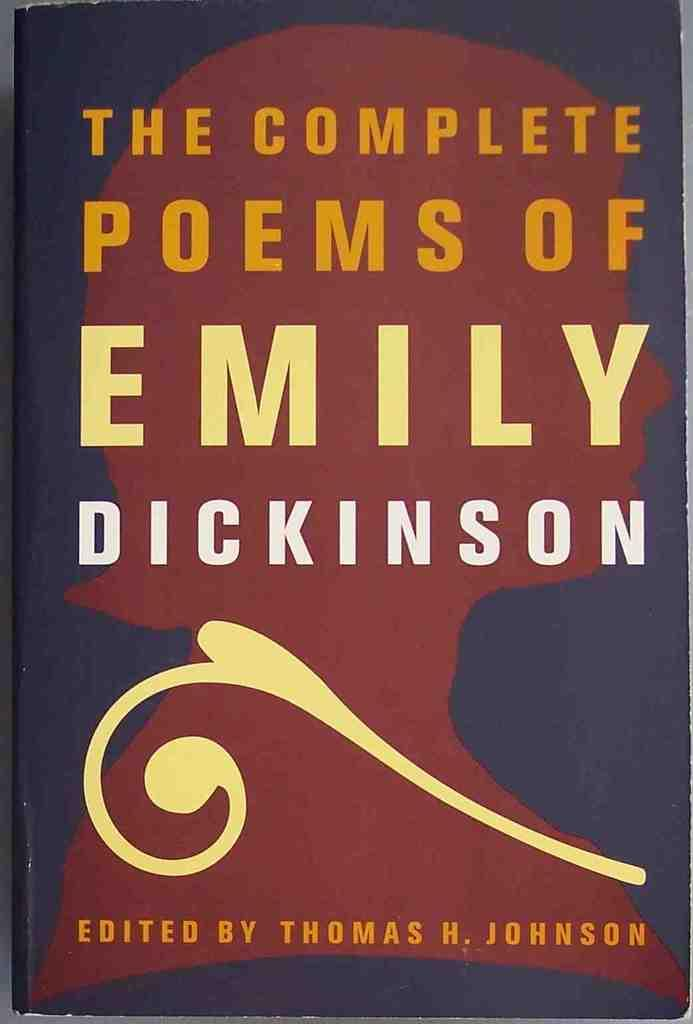Provide a one-sentence caption for the provided image. A cover of the Complete Poems of Emily Dickinson. 